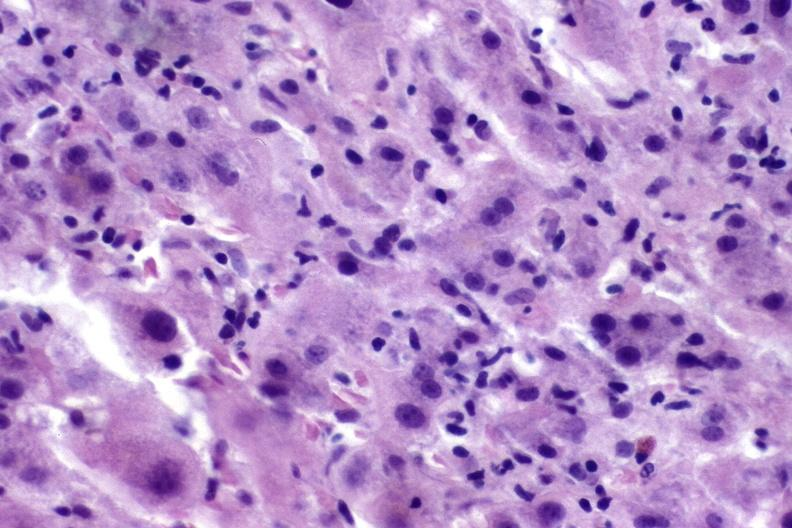s foot present?
Answer the question using a single word or phrase. No 